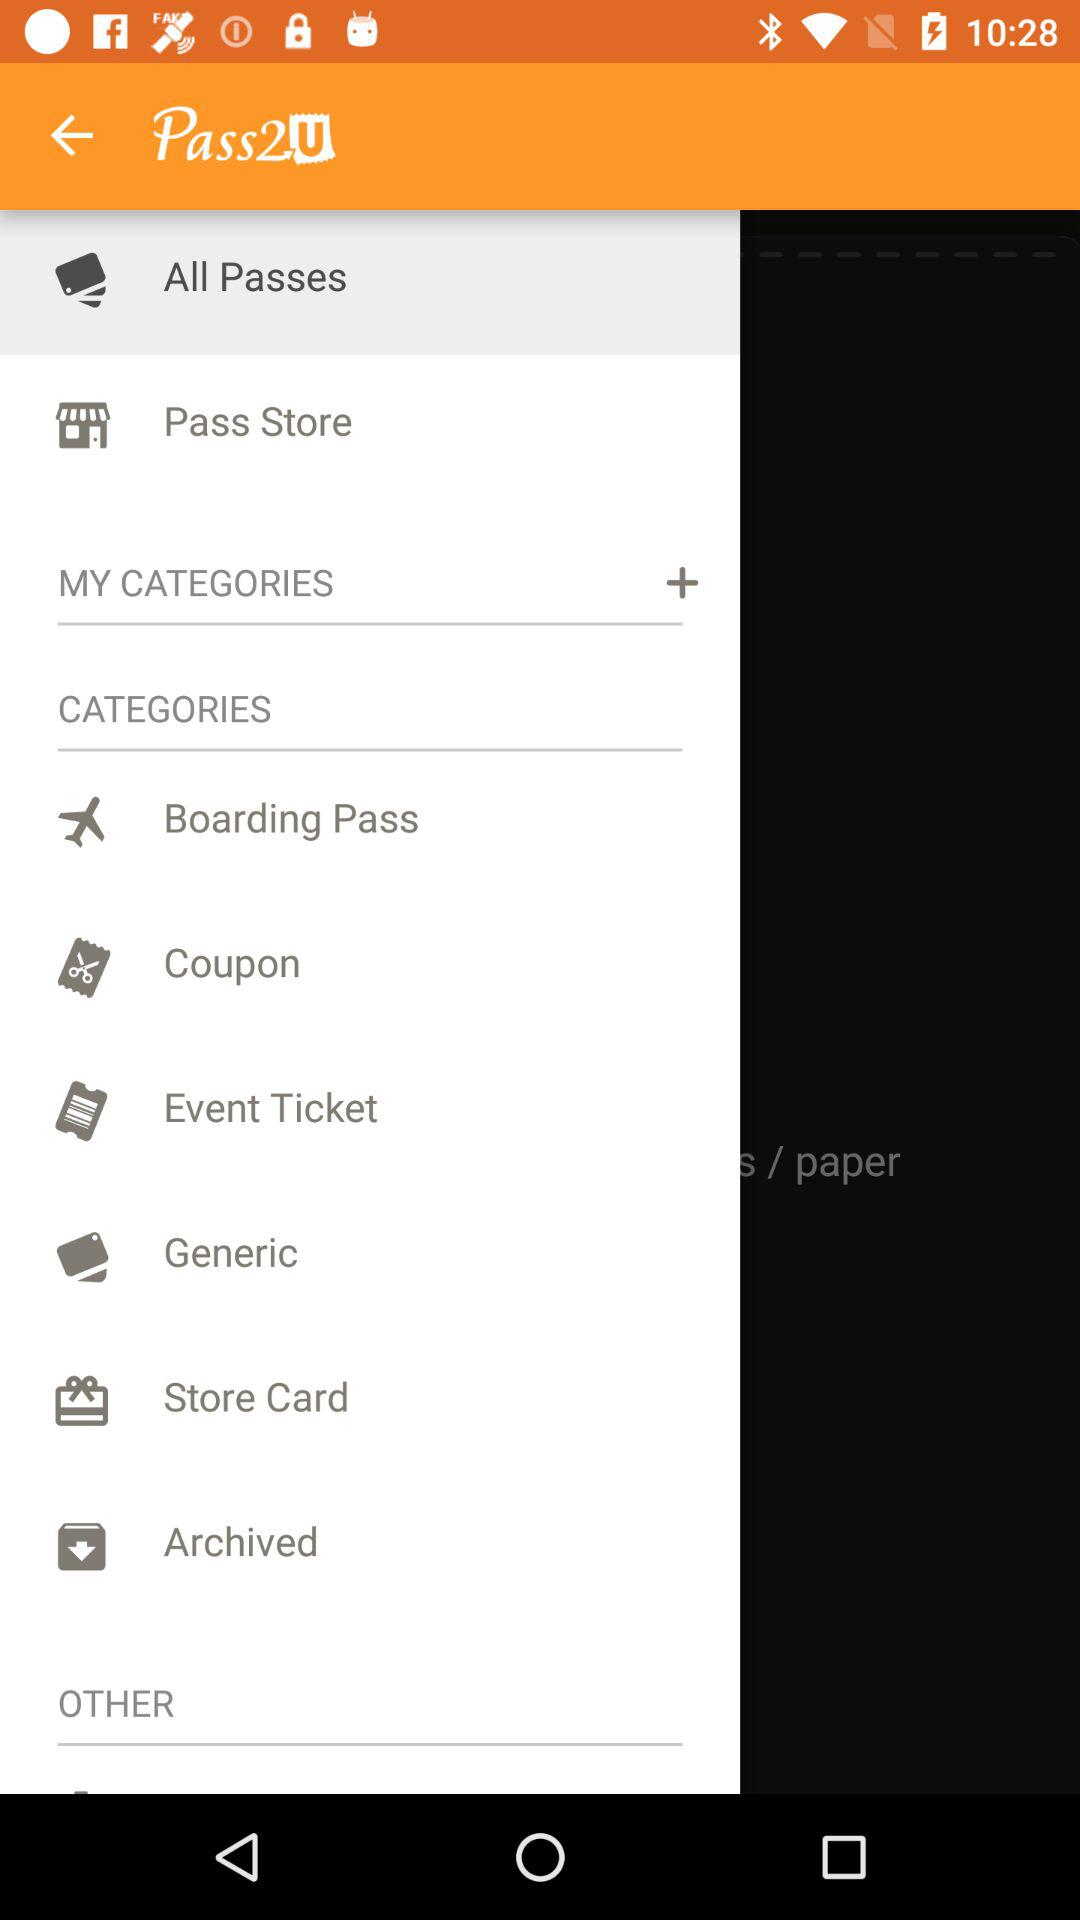What option is selected? The selected option is "All Passes". 